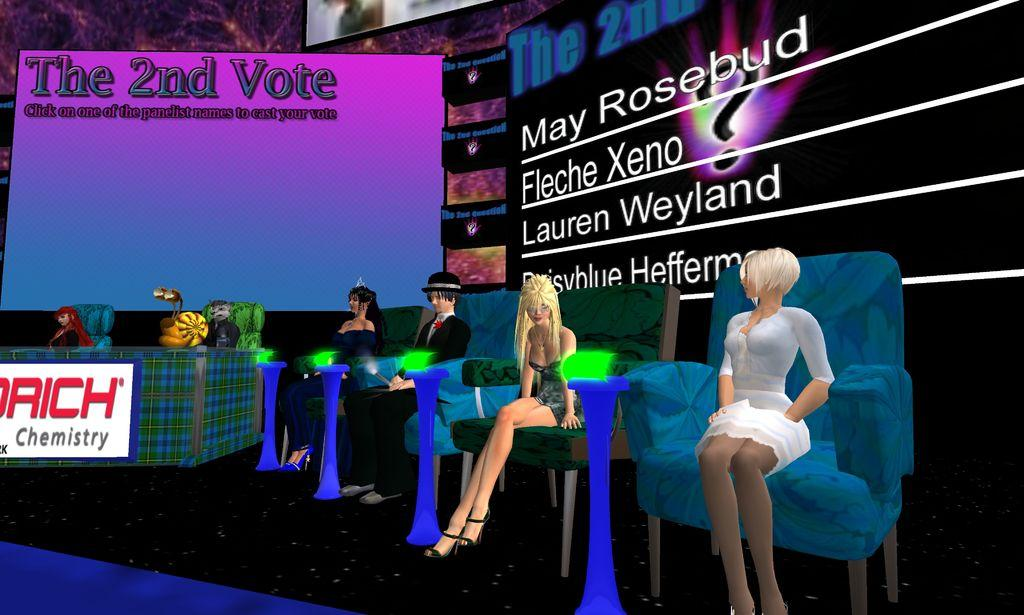What type of characters are in the image? There are cartoon people in the image. What are the cartoon people doing in the image? The cartoon people are sitting. How are the cartoon people dressed? The cartoon people are wearing multi-color dresses. What can be seen in the background of the image? There are screens in the background of the image. What colors are present on the screens? The screens have black, pink, and blue colors. What type of treatment is being administered to the cartoon people in the image? There is no indication of any treatment being administered to the cartoon people in the image. Are the cartoon people crying in the image? There is no indication of the cartoon people crying in the image. 